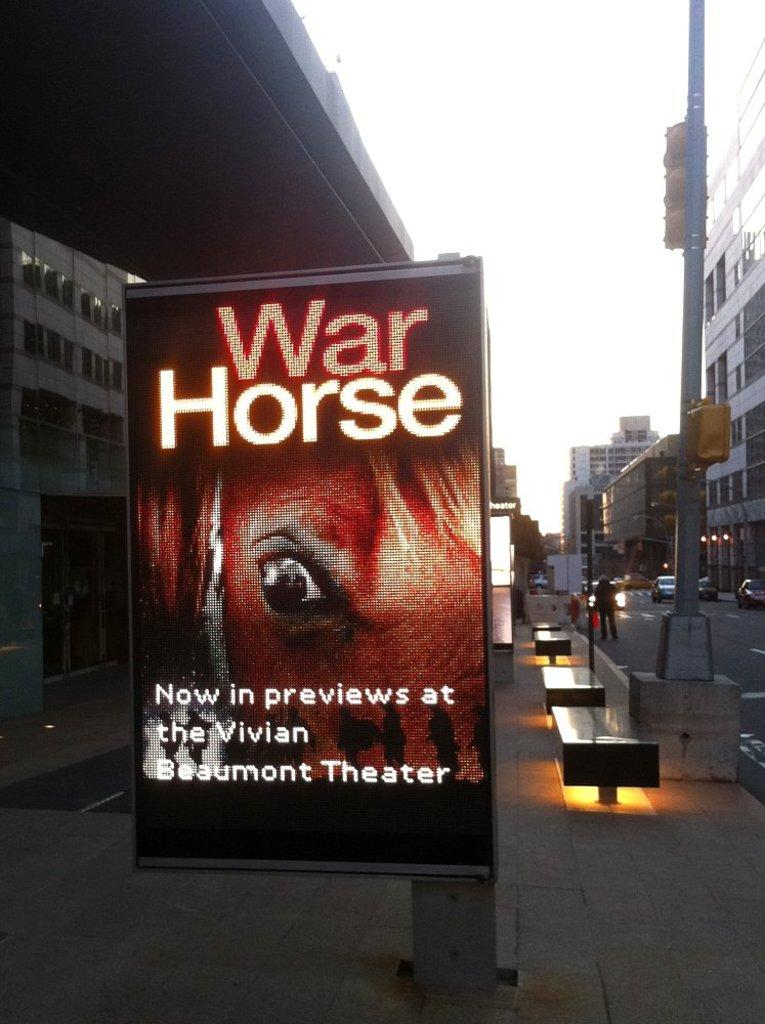<image>
Give a short and clear explanation of the subsequent image. An electronic advertisement featuring the movie war horse. 